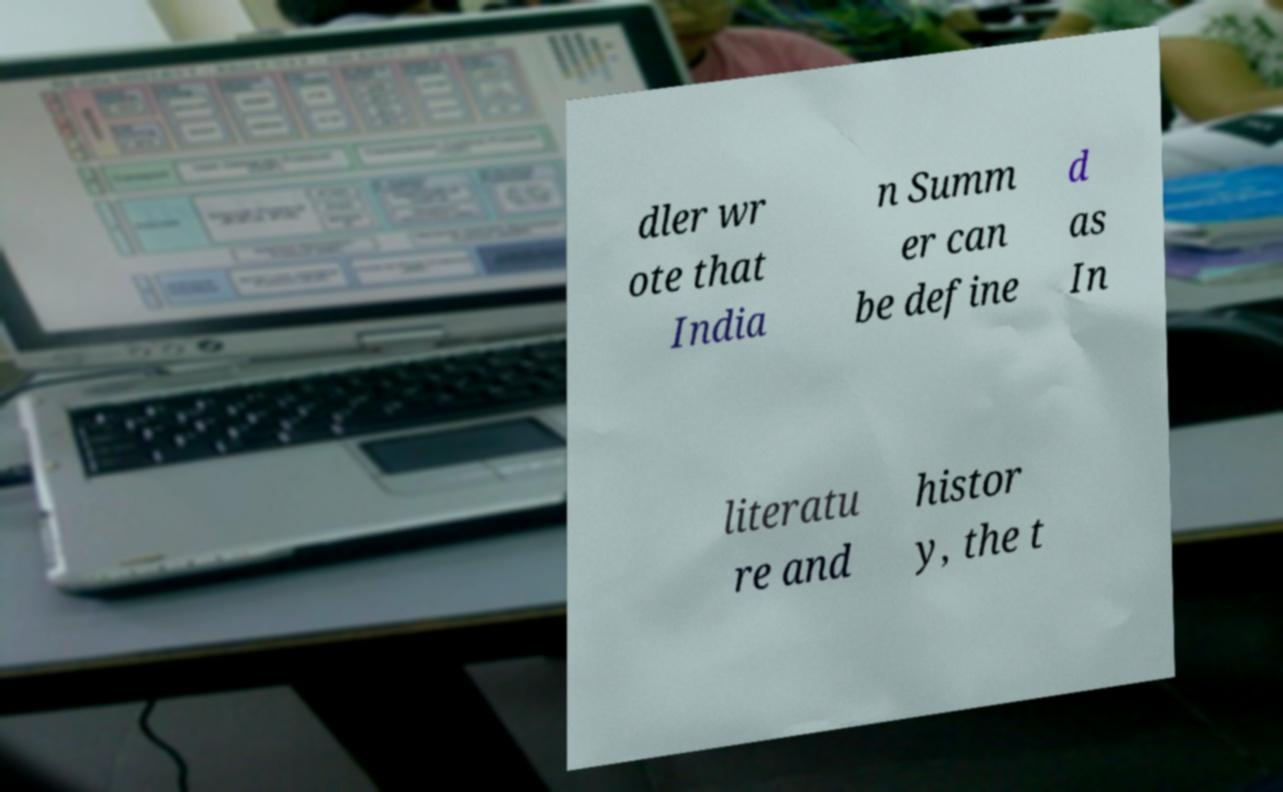For documentation purposes, I need the text within this image transcribed. Could you provide that? dler wr ote that India n Summ er can be define d as In literatu re and histor y, the t 